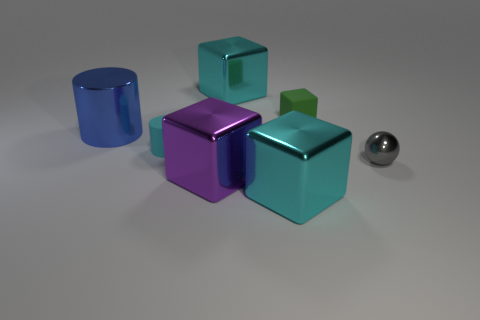Subtract all green balls. How many cyan blocks are left? 2 Add 2 tiny rubber things. How many objects exist? 9 Subtract all cylinders. How many objects are left? 5 Subtract all brown cubes. Subtract all yellow balls. How many cubes are left? 4 Add 7 small green things. How many small green things are left? 8 Add 2 tiny cyan matte objects. How many tiny cyan matte objects exist? 3 Subtract 0 purple cylinders. How many objects are left? 7 Subtract all big rubber things. Subtract all big blue cylinders. How many objects are left? 6 